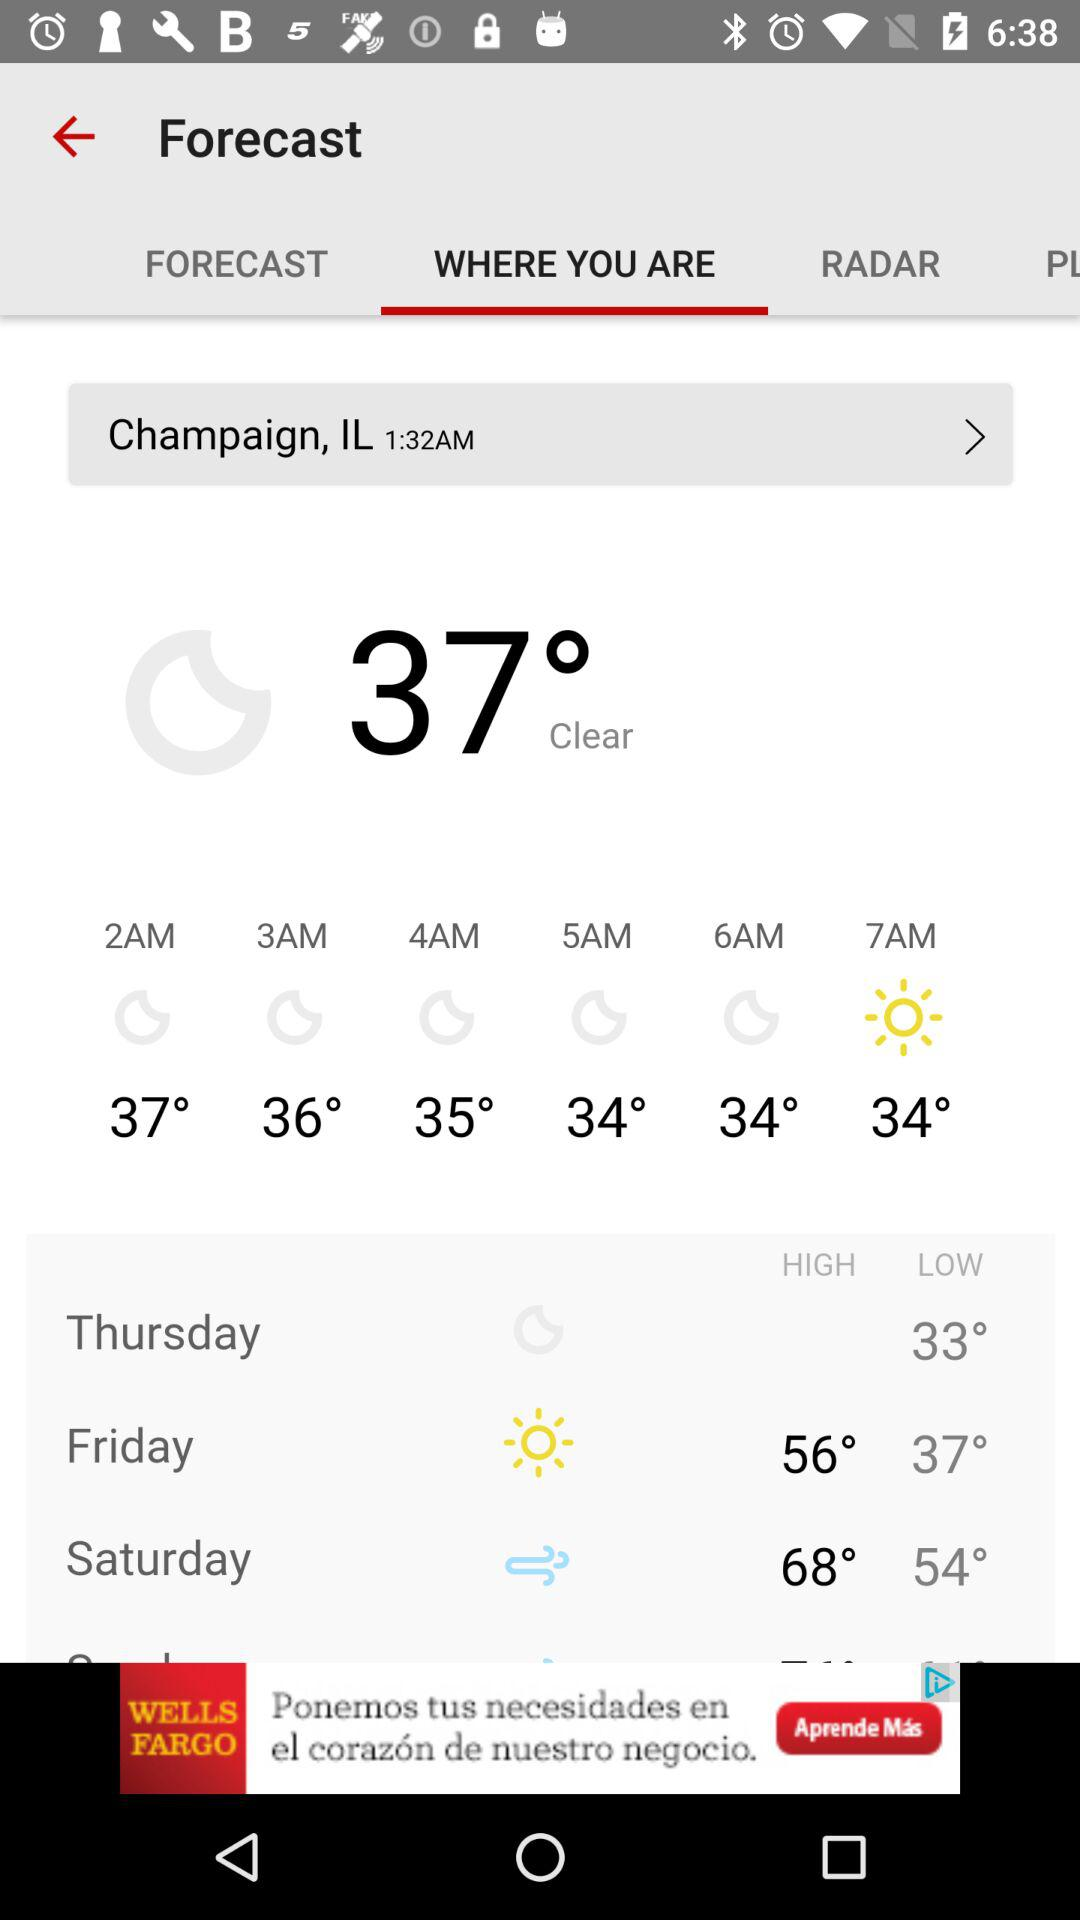Which tab has been selected? The tab that has been selected is "WHERE YOU ARE". 